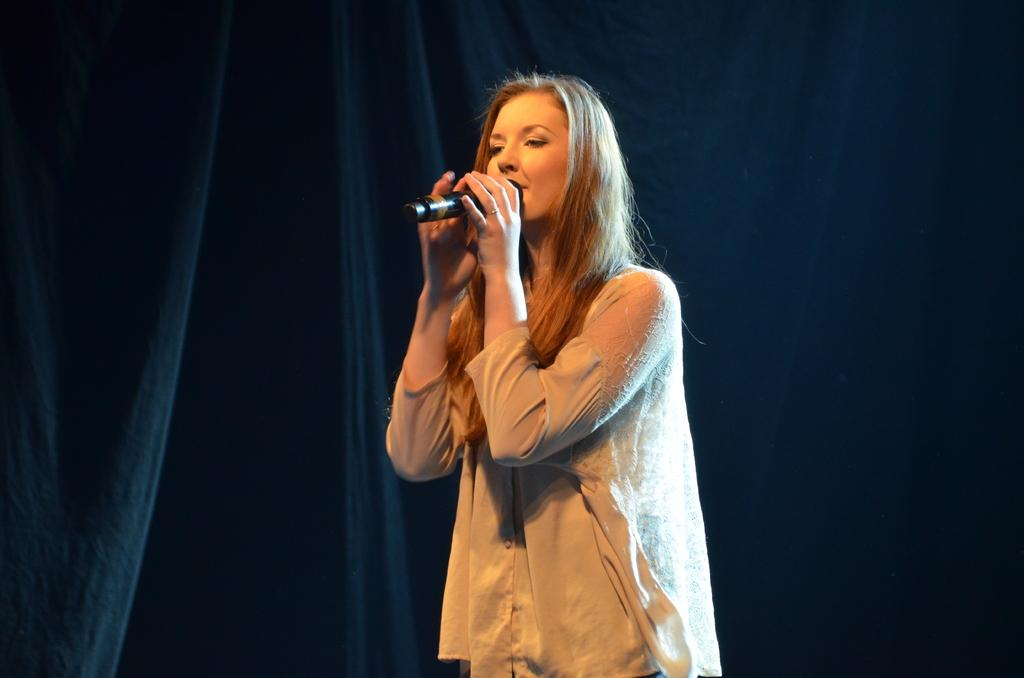What is the main subject of the image? The main subject of the image is a woman. What is the woman holding in the image? The woman is holding a mic. What type of ray can be seen swimming in the background of the image? There is no ray present in the image; it only features a woman holding a mic. 